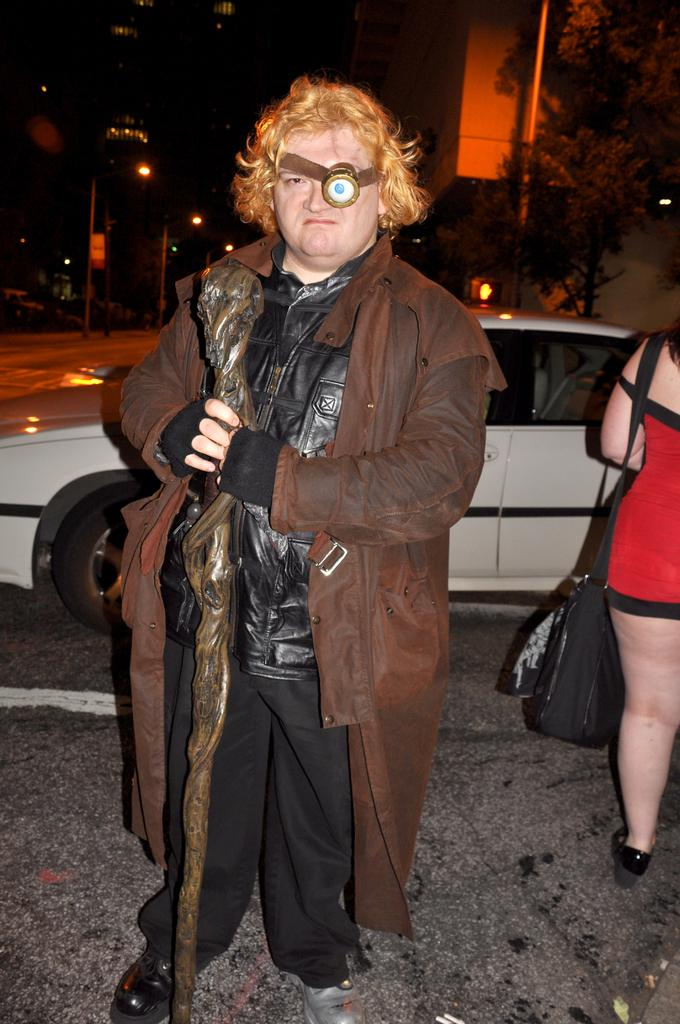What is the person in the image holding? The person is holding a stick in the image. Can you describe the person's clothing? The person is wearing a wire jacket. What is the woman in the image carrying? The woman is wearing a bag in the image. What can be seen in the background of the image? There are trees, buildings, light poles, and a vehicle in the background of the image. What type of alarm can be heard going off in the image? There is no alarm present in the image, and therefore no such sound can be heard. Is the person in the image embarking on a voyage? There is no indication of a voyage in the image; the person is simply holding a stick. 